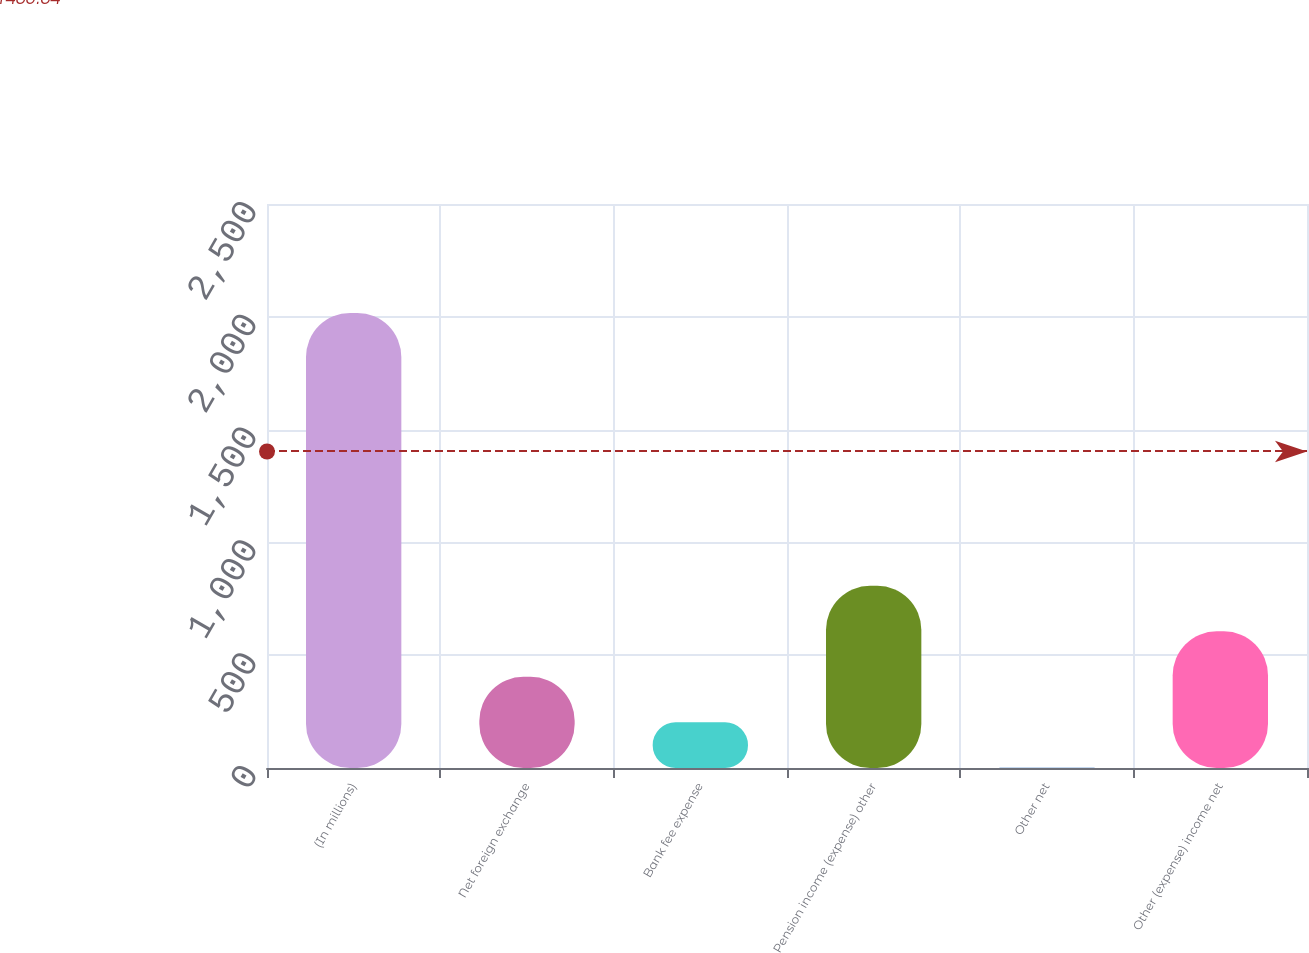Convert chart to OTSL. <chart><loc_0><loc_0><loc_500><loc_500><bar_chart><fcel>(In millions)<fcel>Net foreign exchange<fcel>Bank fee expense<fcel>Pension income (expense) other<fcel>Other net<fcel>Other (expense) income net<nl><fcel>2017<fcel>404.36<fcel>202.78<fcel>807.52<fcel>1.2<fcel>605.94<nl></chart> 